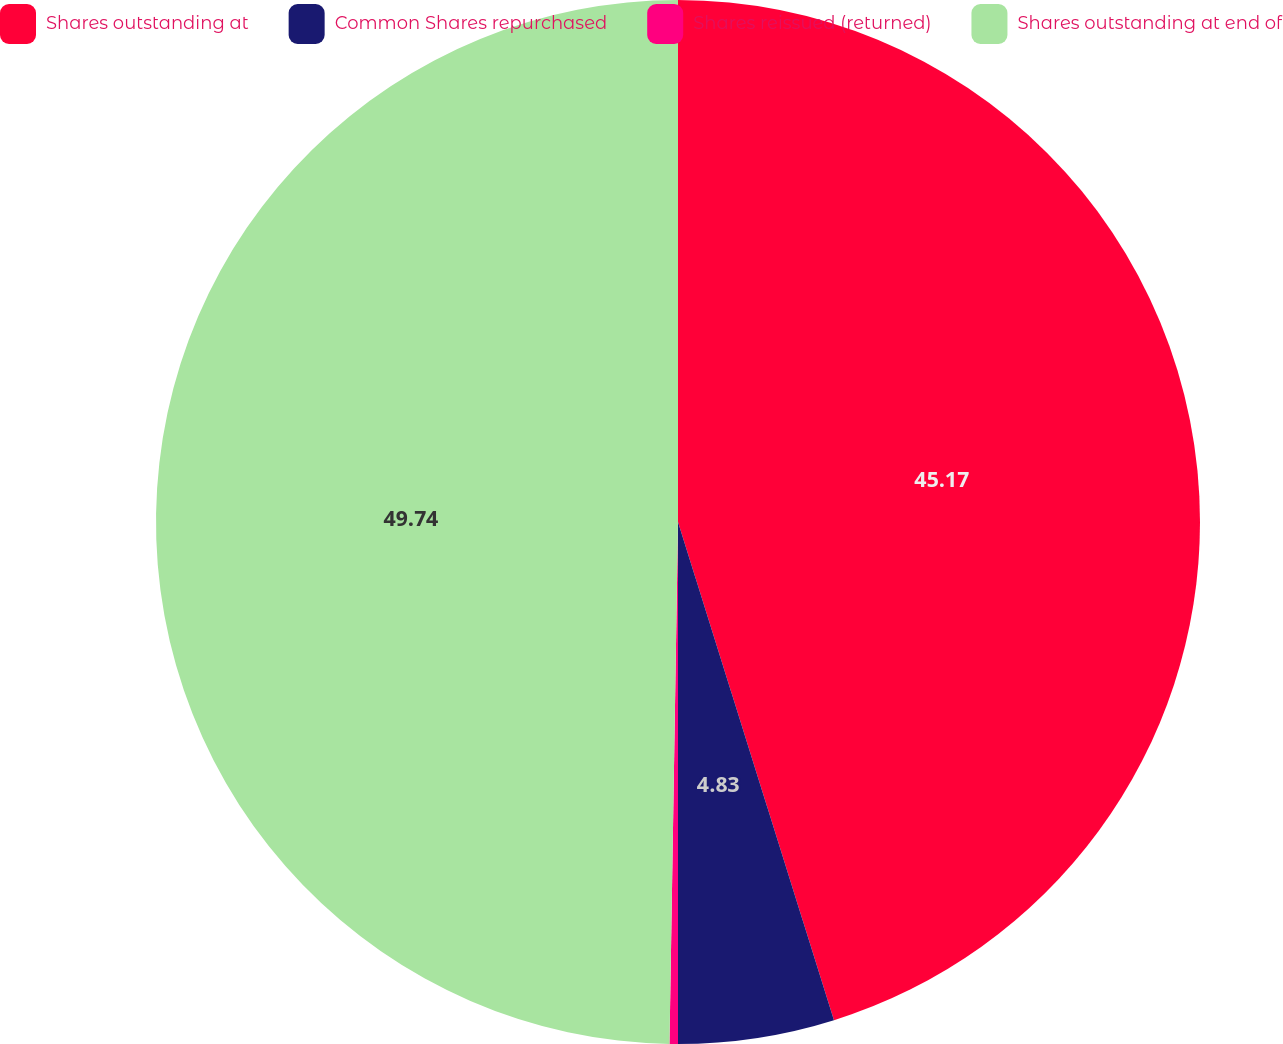Convert chart to OTSL. <chart><loc_0><loc_0><loc_500><loc_500><pie_chart><fcel>Shares outstanding at<fcel>Common Shares repurchased<fcel>Shares reissued (returned)<fcel>Shares outstanding at end of<nl><fcel>45.17%<fcel>4.83%<fcel>0.26%<fcel>49.74%<nl></chart> 